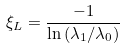Convert formula to latex. <formula><loc_0><loc_0><loc_500><loc_500>\xi _ { L } = \frac { - 1 } { \ln \left ( \lambda _ { 1 } / \lambda _ { 0 } \right ) }</formula> 